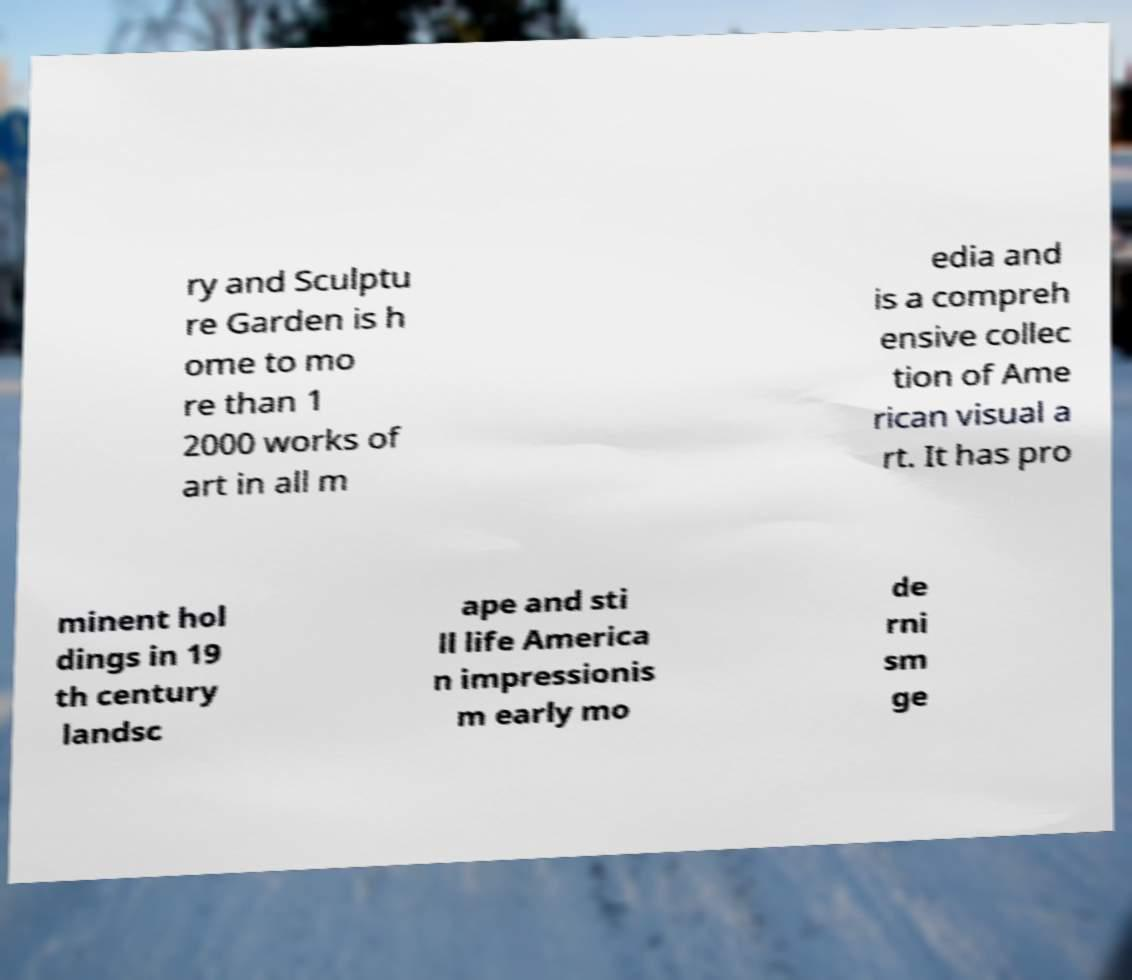For documentation purposes, I need the text within this image transcribed. Could you provide that? ry and Sculptu re Garden is h ome to mo re than 1 2000 works of art in all m edia and is a compreh ensive collec tion of Ame rican visual a rt. It has pro minent hol dings in 19 th century landsc ape and sti ll life America n impressionis m early mo de rni sm ge 